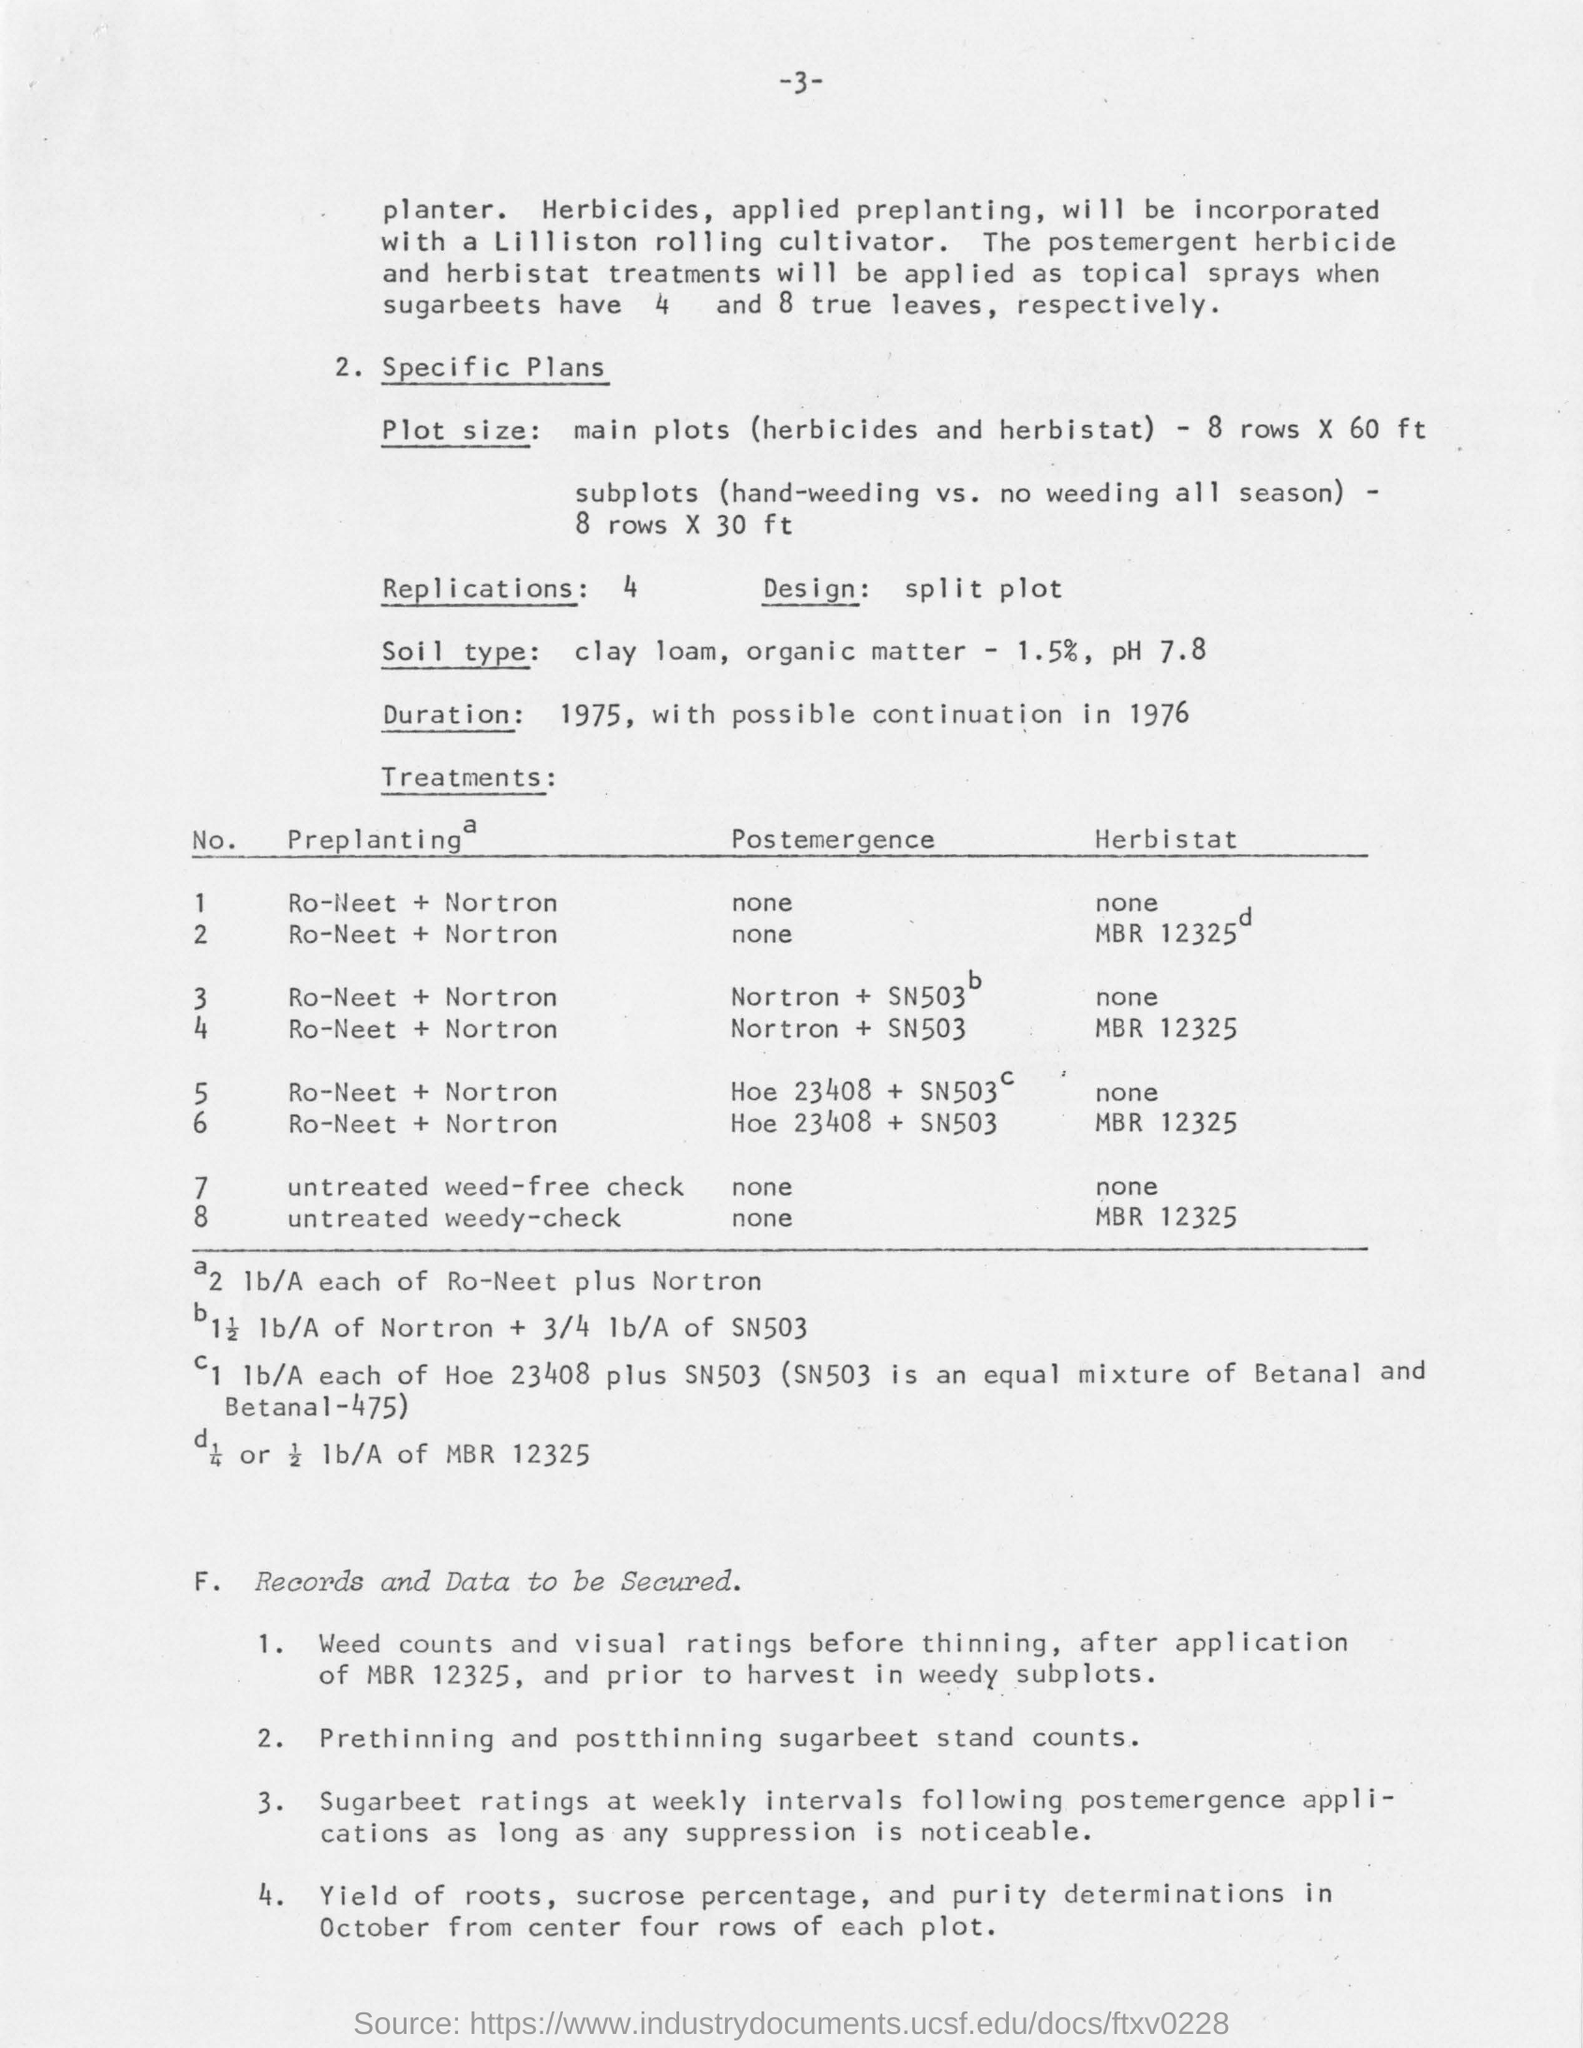Which treatments will be applied as topical sprays when sugarbeets have 4 and 8 true leaves respectively?
Make the answer very short. The postemergent herbicide and herbistat treatments. What is the rate of organic matter present in clay loam soil?
Your answer should be very brief. 1.5. What is the plot size for subplots(hand weeding vs no weeding all season)?
Your response must be concise. 8 rows X 30 ft. What is the ph value for clay loam soil?
Ensure brevity in your answer.  7.8. 